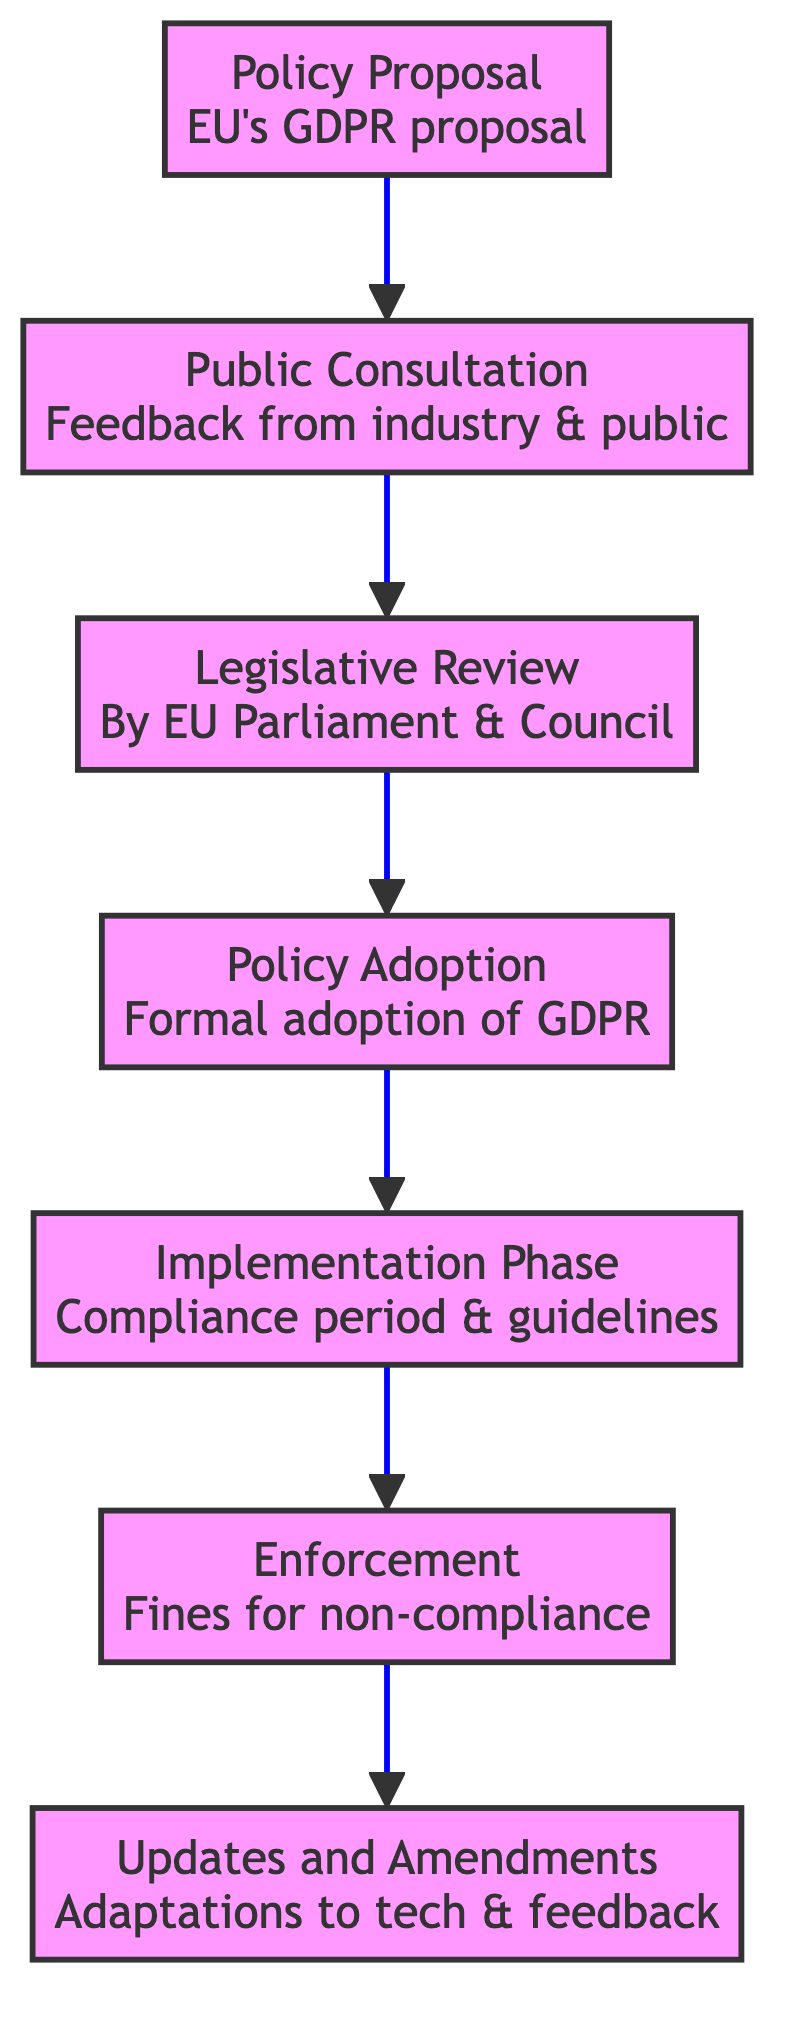What is the first step in the process? The first step in the diagram is represented by the node labeled "Policy Proposal," which details the EU's GDPR proposal.
Answer: Policy Proposal How many nodes are in the diagram? The diagram contains seven nodes, each representing a different stage in the regulatory process impacting technology companies.
Answer: 7 What node follows the "Public Consultation"? Following the "Public Consultation" node, which focuses on gathering feedback, is the "Legislative Review" node where the proposal is reviewed by the European Parliament and the Council.
Answer: Legislative Review Which node represents the formal adoption of GDPR? The node labeled "Policy Adoption" signifies the stage where GDPR is formally adopted by the EU Parliament, marking a crucial stage in the regulatory process.
Answer: Policy Adoption What is linked directly after "Implementation Phase"? The "Enforcement" node is linked directly after the "Implementation Phase," indicating that after tech companies implement the policies, enforcement actions begin.
Answer: Enforcement How does the "Enforcement" node relate to penalties? The "Enforcement" node discusses "Fines and penalties for non-compliance," suggesting that this is the phase where penalties are applied to violators of the policy.
Answer: Fines and penalties Is there a feedback mechanism reflected in the diagram? Yes, the "Updates and Amendments" node at the end indicates that adaptations occur in response to technological advancements and industry feedback, representing a feedback mechanism.
Answer: Yes What comes last in the sequence of the diagram? The last node in the sequence is "Updates and Amendments," which indicates the ongoing adaptation of policies based on feedback and advancements in technology.
Answer: Updates and Amendments What is the connection between "Policy Adoption" and "Implementation Phase"? The connection is direct, showing that after the "Policy Adoption" stage, the next logical step is the "Implementation Phase" where compliance becomes mandatory.
Answer: Implementation Phase 